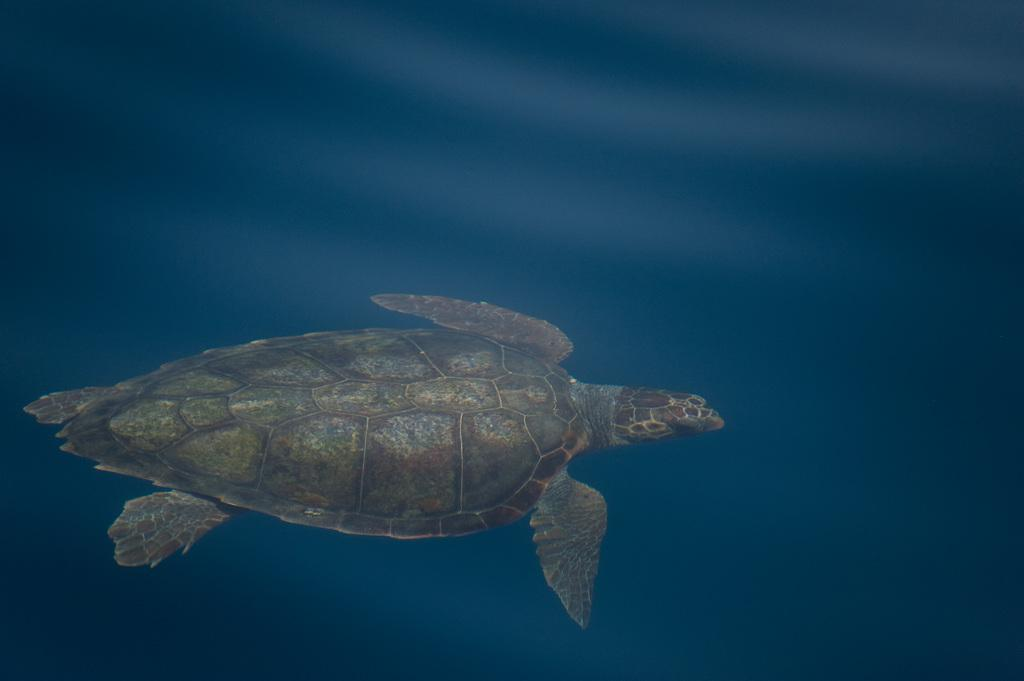What animal is present in the image? There is a turtle in the image. Where is the turtle located? The turtle is in the water. What books can be seen on the turtle's back in the image? There are no books present in the image, as it features a turtle in the water. 